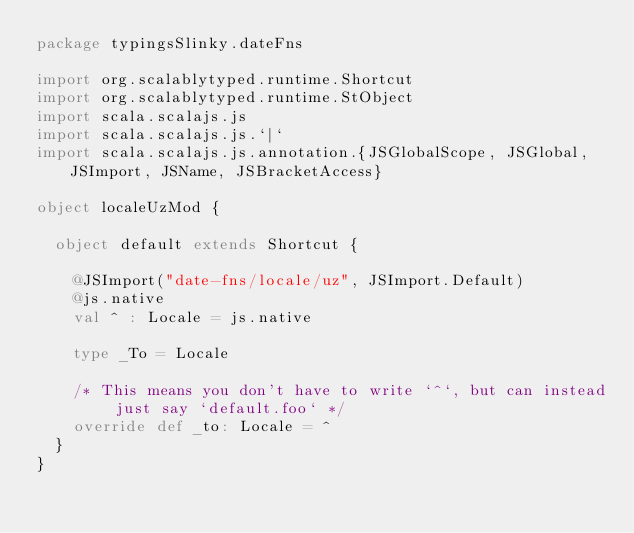Convert code to text. <code><loc_0><loc_0><loc_500><loc_500><_Scala_>package typingsSlinky.dateFns

import org.scalablytyped.runtime.Shortcut
import org.scalablytyped.runtime.StObject
import scala.scalajs.js
import scala.scalajs.js.`|`
import scala.scalajs.js.annotation.{JSGlobalScope, JSGlobal, JSImport, JSName, JSBracketAccess}

object localeUzMod {
  
  object default extends Shortcut {
    
    @JSImport("date-fns/locale/uz", JSImport.Default)
    @js.native
    val ^ : Locale = js.native
    
    type _To = Locale
    
    /* This means you don't have to write `^`, but can instead just say `default.foo` */
    override def _to: Locale = ^
  }
}
</code> 